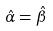<formula> <loc_0><loc_0><loc_500><loc_500>\hat { \alpha } = \hat { \beta }</formula> 